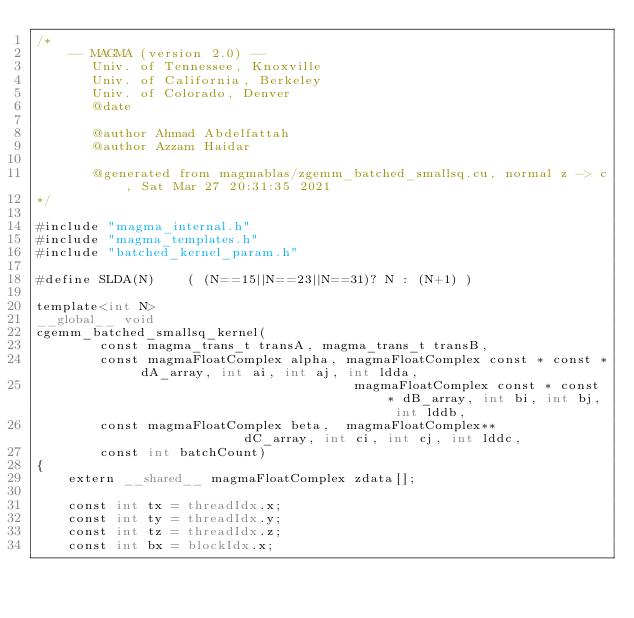Convert code to text. <code><loc_0><loc_0><loc_500><loc_500><_Cuda_>/*
    -- MAGMA (version 2.0) --
       Univ. of Tennessee, Knoxville
       Univ. of California, Berkeley
       Univ. of Colorado, Denver
       @date

       @author Ahmad Abdelfattah
       @author Azzam Haidar

       @generated from magmablas/zgemm_batched_smallsq.cu, normal z -> c, Sat Mar 27 20:31:35 2021
*/

#include "magma_internal.h"
#include "magma_templates.h"
#include "batched_kernel_param.h"

#define SLDA(N)    ( (N==15||N==23||N==31)? N : (N+1) )

template<int N>
__global__ void
cgemm_batched_smallsq_kernel(
        const magma_trans_t transA, magma_trans_t transB, 
        const magmaFloatComplex alpha, magmaFloatComplex const * const * dA_array, int ai, int aj, int ldda, 
                                        magmaFloatComplex const * const * dB_array, int bi, int bj, int lddb, 
        const magmaFloatComplex beta,  magmaFloatComplex**               dC_array, int ci, int cj, int lddc, 
        const int batchCount)
{
    extern __shared__ magmaFloatComplex zdata[];

    const int tx = threadIdx.x;
    const int ty = threadIdx.y;
    const int tz = threadIdx.z;
    const int bx = blockIdx.x;
    </code> 